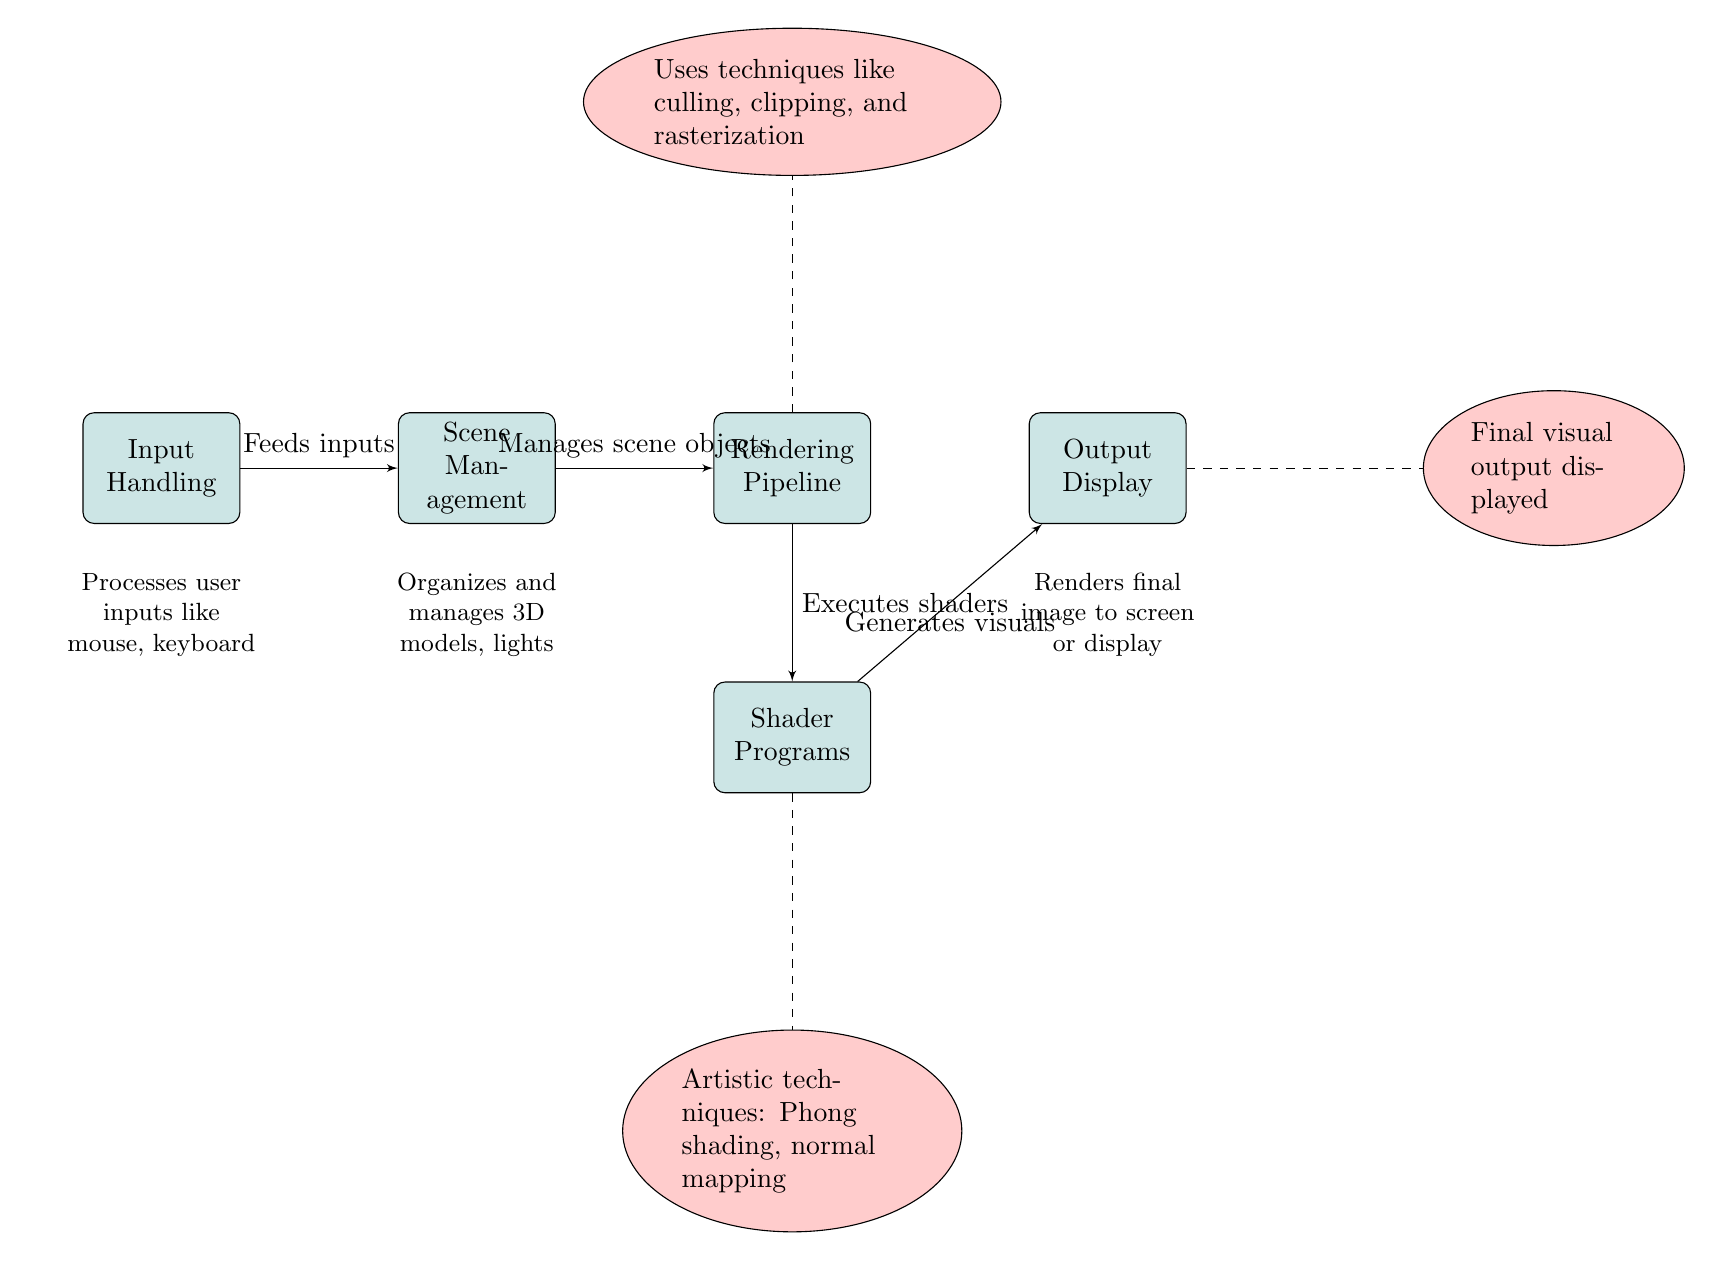What's the first component in the architecture of the graphics rendering engine? The diagram indicates "Input Handling" as the first block in the flow of the graphics rendering engine.
Answer: Input Handling How many main components are detailed in the diagram? The diagram includes five main components: Input Handling, Scene Management, Rendering Pipeline, Shader Programs, and Output Display.
Answer: Five What is the relationship between Scene Management and Rendering Pipeline? The arrow between Scene Management and Rendering Pipeline indicates that Scene Management "Manages scene objects" which are then passed to the Rendering Pipeline.
Answer: Manages scene objects What techniques are applied in the Shader Programs? The annotation connected to Shader Programs mentions techniques such as "Phong shading" and "normal mapping" as artistic techniques applied to enhance visuals.
Answer: Phong shading, normal mapping Which component executes shaders? The diagram shows that the Rendering Pipeline is responsible for executing shaders as indicated by the label "Executes shaders" on the connecting line to Shader Programs.
Answer: Rendering Pipeline What does the Output Display represent in the rendering engine? The Output Display is described in the diagram as "Final visual output displayed," indicating it is the endpoint where the visuals are shown to the user.
Answer: Final visual output displayed What aspect of rendering does the annotation connected to the Rendering Pipeline address? The annotation near the Rendering Pipeline describes techniques like "culling, clipping, and rasterization," which are essential processes in the rendering stage.
Answer: Culling, clipping, and rasterization Which component receives inputs directly? Input Handling is the component that processes and receives user inputs directly from devices like the mouse and keyboard, as indicated in the description below the block.
Answer: Input Handling How does the Shader Programs component contribute to the visual output? The Shader Programs are responsible for generating visuals and are connected to the Output Display, implying that they transform the processed data into final images.
Answer: Generates visuals 